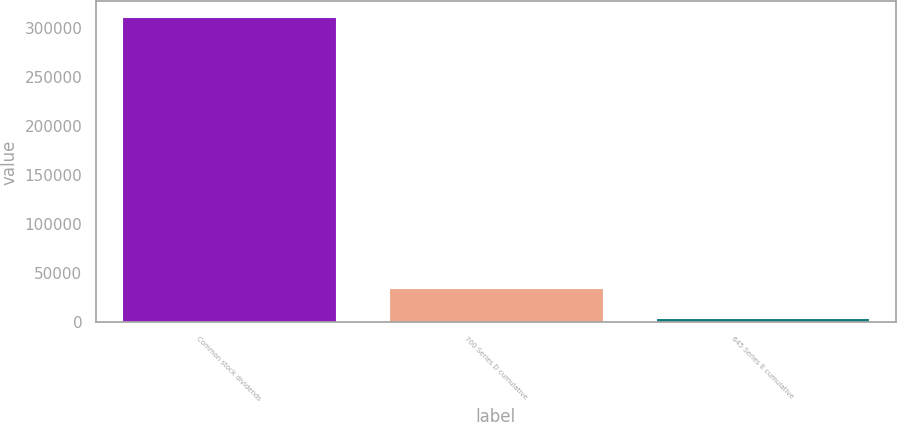Convert chart to OTSL. <chart><loc_0><loc_0><loc_500><loc_500><bar_chart><fcel>Common stock dividends<fcel>700 Series D cumulative<fcel>645 Series E cumulative<nl><fcel>312131<fcel>34986.8<fcel>4193<nl></chart> 